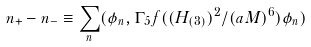Convert formula to latex. <formula><loc_0><loc_0><loc_500><loc_500>n _ { + } - n _ { - } \equiv \sum _ { n } ( \phi _ { n } , \Gamma _ { 5 } f ( ( H _ { ( 3 ) } ) ^ { 2 } / ( a M ) ^ { 6 } ) \phi _ { n } )</formula> 